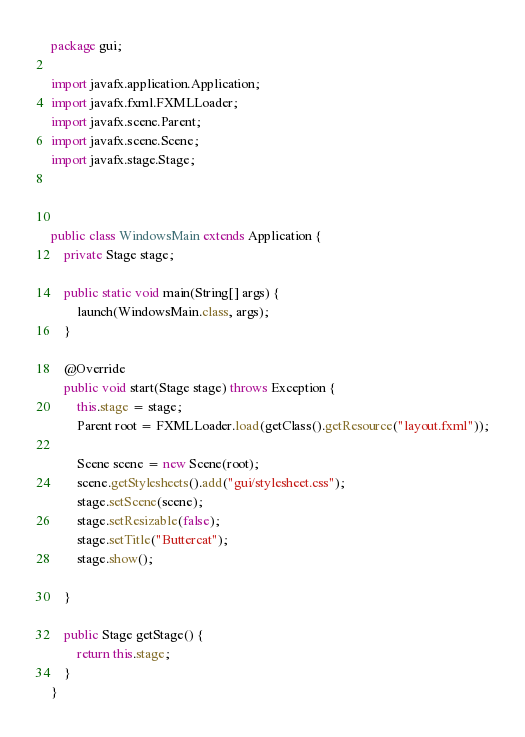<code> <loc_0><loc_0><loc_500><loc_500><_Java_>package gui;

import javafx.application.Application;
import javafx.fxml.FXMLLoader;
import javafx.scene.Parent;
import javafx.scene.Scene;
import javafx.stage.Stage;



public class WindowsMain extends Application {
    private Stage stage;

    public static void main(String[] args) {
        launch(WindowsMain.class, args);
    }

    @Override
    public void start(Stage stage) throws Exception {
        this.stage = stage;
        Parent root = FXMLLoader.load(getClass().getResource("layout.fxml"));

        Scene scene = new Scene(root);
        scene.getStylesheets().add("gui/stylesheet.css");
        stage.setScene(scene);
        stage.setResizable(false);
        stage.setTitle("Buttercat");
        stage.show();

    }

    public Stage getStage() {
        return this.stage;
    }
}
</code> 